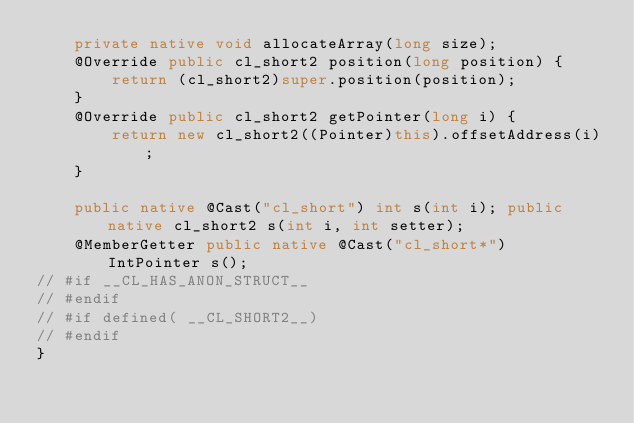<code> <loc_0><loc_0><loc_500><loc_500><_Java_>    private native void allocateArray(long size);
    @Override public cl_short2 position(long position) {
        return (cl_short2)super.position(position);
    }
    @Override public cl_short2 getPointer(long i) {
        return new cl_short2((Pointer)this).offsetAddress(i);
    }

    public native @Cast("cl_short") int s(int i); public native cl_short2 s(int i, int setter);
    @MemberGetter public native @Cast("cl_short*") IntPointer s();
// #if __CL_HAS_ANON_STRUCT__
// #endif
// #if defined( __CL_SHORT2__)
// #endif
}
</code> 